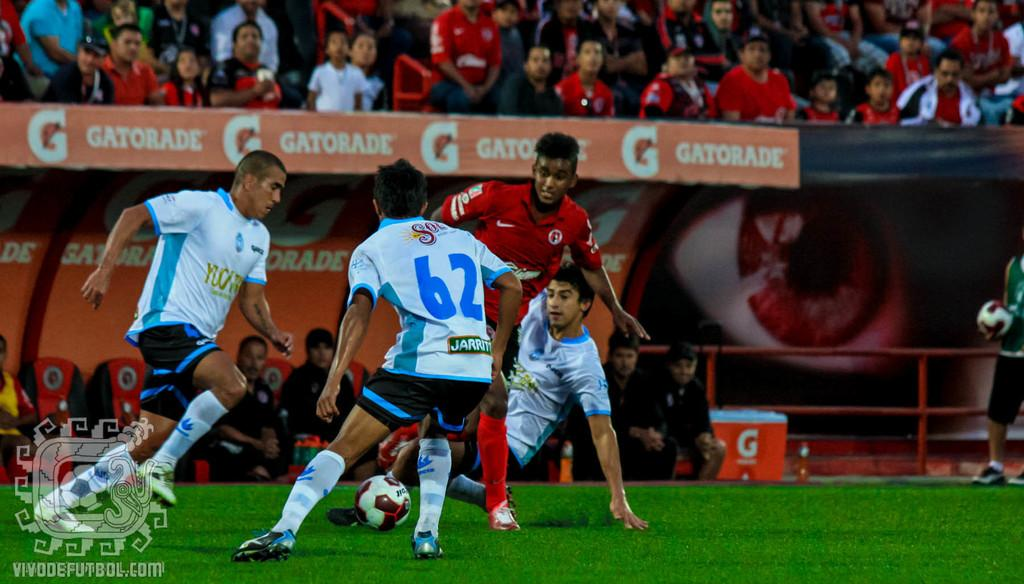Provide a one-sentence caption for the provided image. Soccer player wearing jersey number 62 about to steal a ball. 